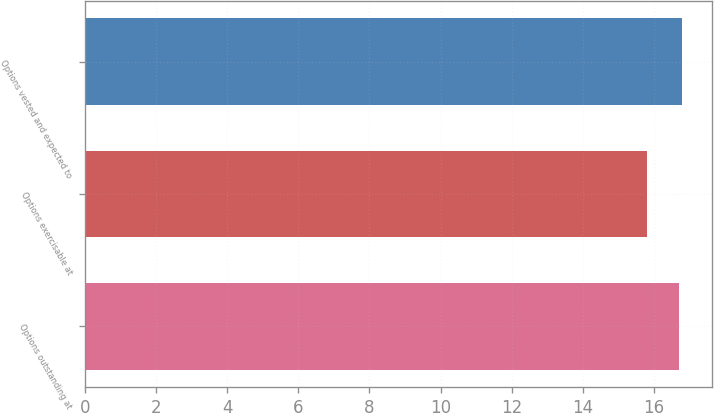Convert chart to OTSL. <chart><loc_0><loc_0><loc_500><loc_500><bar_chart><fcel>Options outstanding at<fcel>Options exercisable at<fcel>Options vested and expected to<nl><fcel>16.7<fcel>15.81<fcel>16.79<nl></chart> 